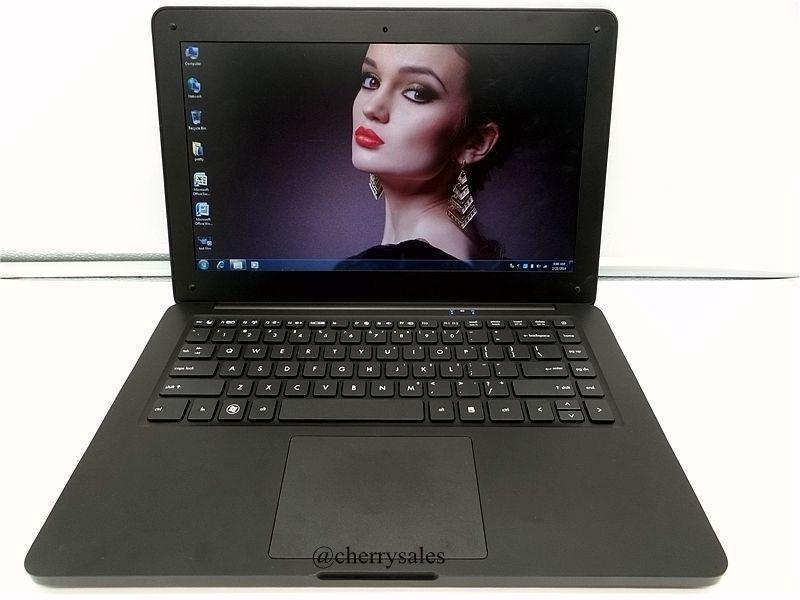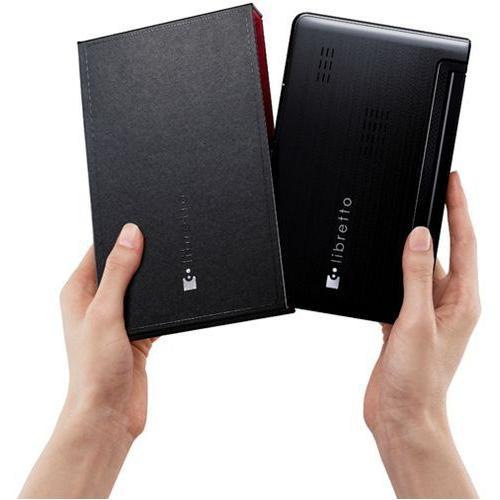The first image is the image on the left, the second image is the image on the right. Examine the images to the left and right. Is the description "An open gold-toned laptop computer is shown in one image." accurate? Answer yes or no. No. The first image is the image on the left, the second image is the image on the right. Given the left and right images, does the statement "One image shows a laptop with a woman's face predominant on the screen." hold true? Answer yes or no. Yes. 